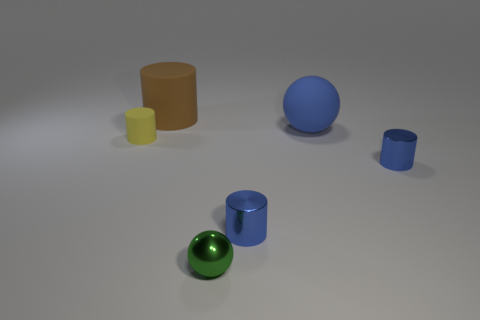Is there a small metal thing on the left side of the small blue metallic thing left of the blue cylinder to the right of the blue sphere?
Your answer should be compact. Yes. The tiny shiny sphere is what color?
Give a very brief answer. Green. Are there any tiny cylinders left of the green thing?
Your answer should be compact. Yes. Does the brown object have the same shape as the big rubber thing right of the green object?
Provide a succinct answer. No. How many other things are the same material as the small yellow object?
Your answer should be very brief. 2. The large thing right of the cylinder that is behind the cylinder that is left of the brown rubber cylinder is what color?
Ensure brevity in your answer.  Blue. What is the shape of the blue thing that is left of the blue object behind the yellow matte cylinder?
Give a very brief answer. Cylinder. Are there more small blue metallic cylinders that are in front of the blue rubber ball than tiny cyan metal balls?
Your answer should be compact. Yes. There is a blue object on the left side of the blue sphere; is its shape the same as the tiny yellow thing?
Offer a terse response. Yes. Is there another yellow thing that has the same shape as the yellow matte object?
Offer a terse response. No. 